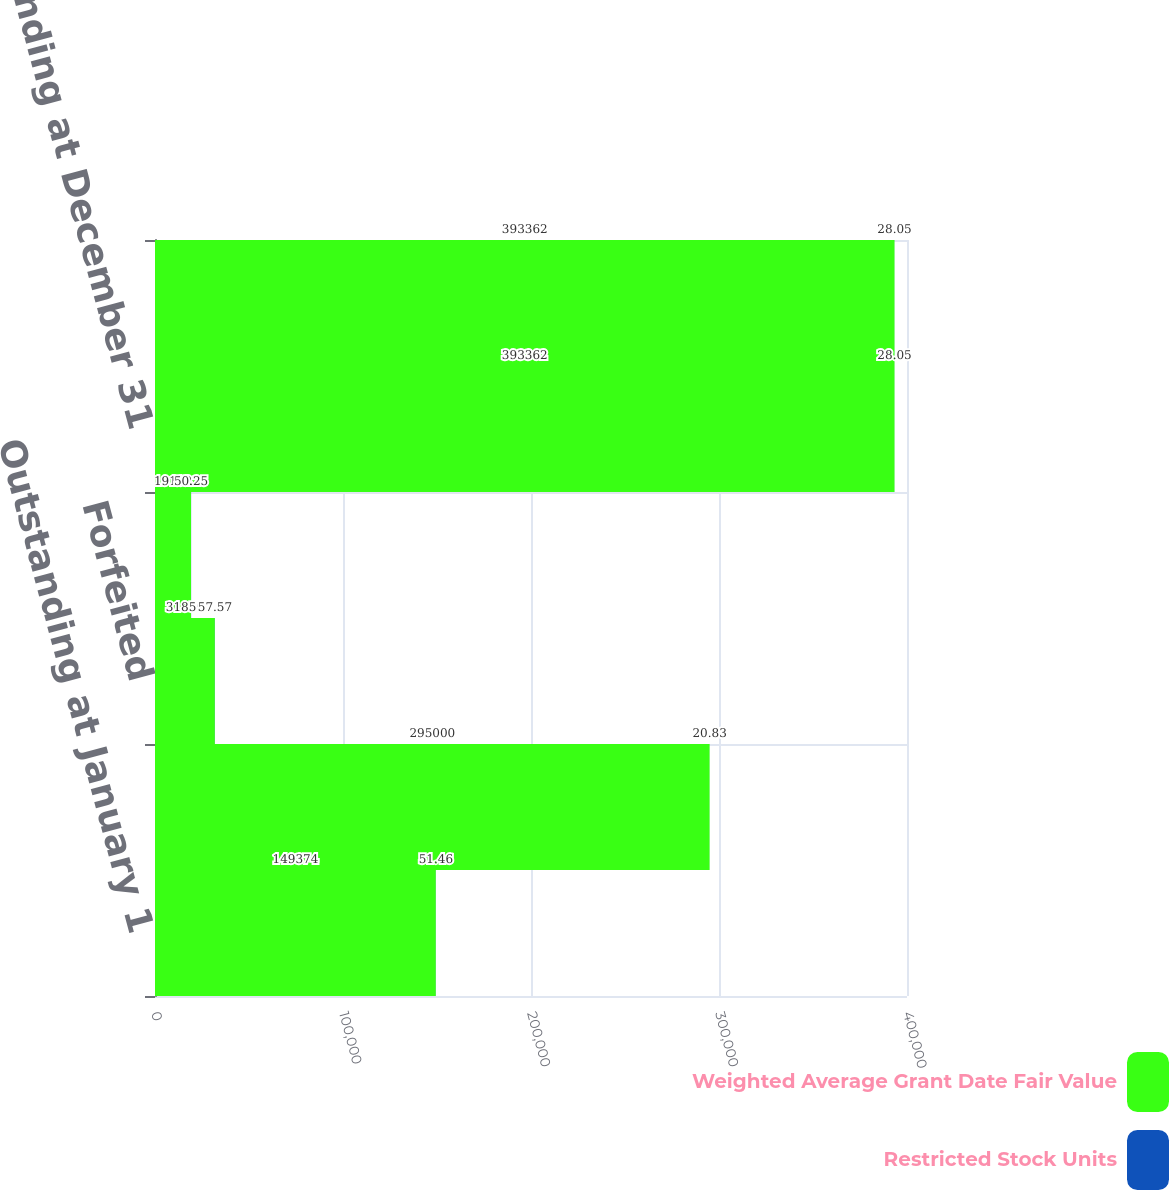<chart> <loc_0><loc_0><loc_500><loc_500><stacked_bar_chart><ecel><fcel>Outstanding at January 1<fcel>Granted<fcel>Forfeited<fcel>Paid<fcel>Outstanding at December 31<fcel>Restricted Stock Units<nl><fcel>Weighted Average Grant Date Fair Value<fcel>149374<fcel>295000<fcel>31850<fcel>19162<fcel>393362<fcel>393362<nl><fcel>Restricted Stock Units<fcel>51.46<fcel>20.83<fcel>57.57<fcel>50.25<fcel>28.05<fcel>28.05<nl></chart> 